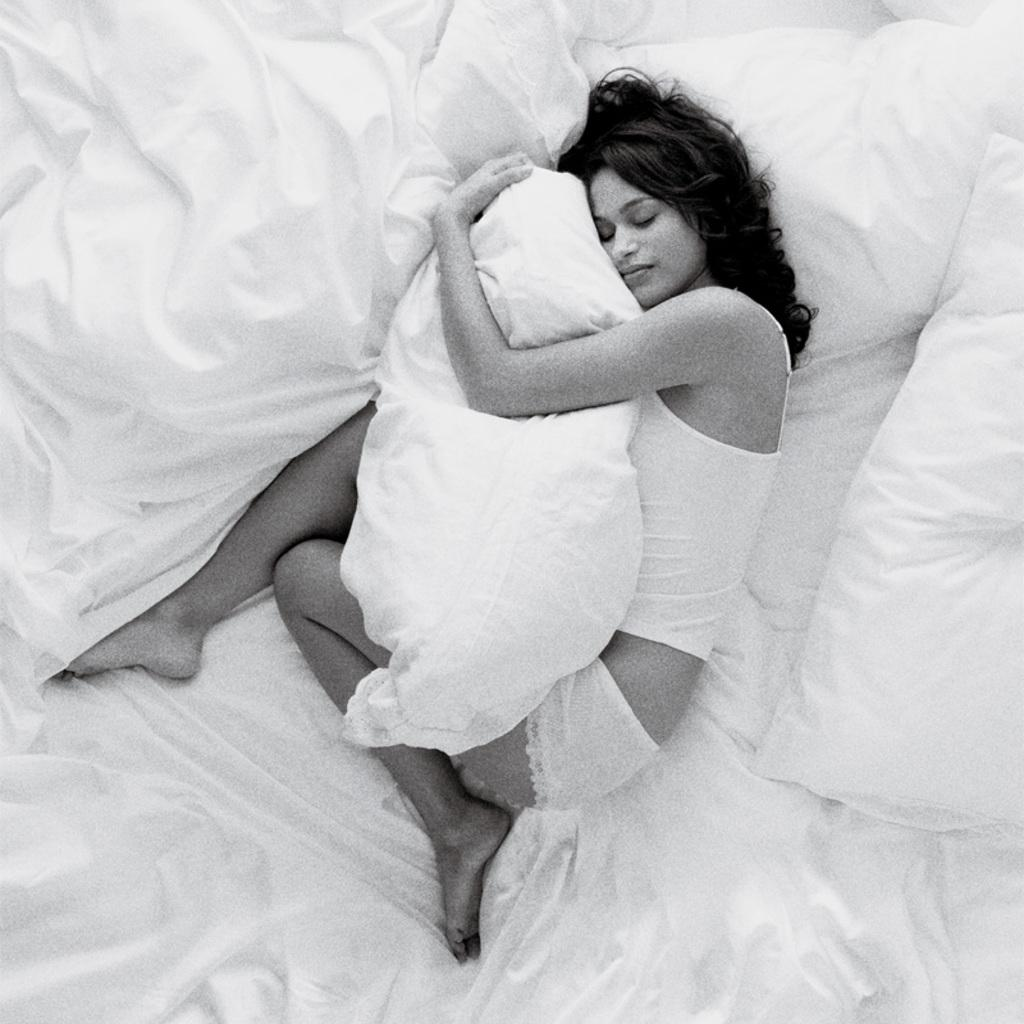Who is present in the image? There is a woman in the image. What is the woman holding in the image? The woman is holding a pillow. What is the woman's position in the image? The woman is lying on a bed. What type of lead can be seen in the image? There is no lead present in the image. What error is the woman making in the image? There is no error being made by the woman in the image. 